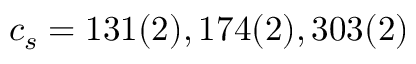Convert formula to latex. <formula><loc_0><loc_0><loc_500><loc_500>c _ { s } = 1 3 1 ( 2 ) , 1 7 4 ( 2 ) , 3 0 3 ( 2 )</formula> 